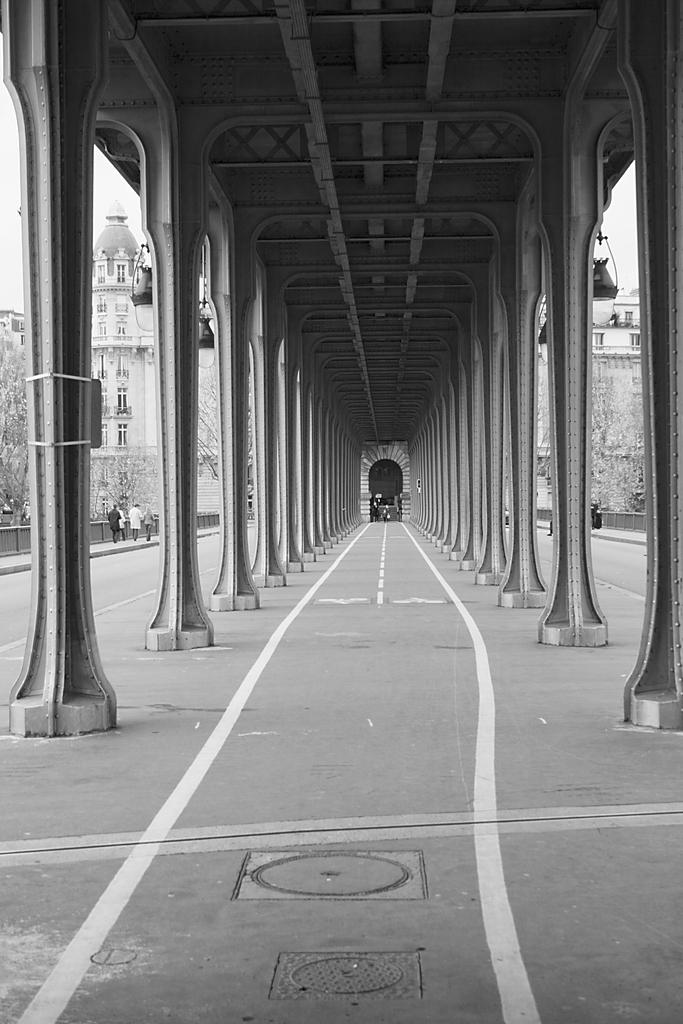What architectural features can be seen in the image? There are pillars in the image. What can be seen illuminating the area in the image? There are lights in the image. What is visible in the background of the image? In the background, there are people, fences, buildings, trees, and the sky. Can you describe the ocean waves in the image? There is no ocean or waves present in the image. What type of love is being expressed by the people in the image? The image does not depict any expressions of love; it only shows people in the background. 